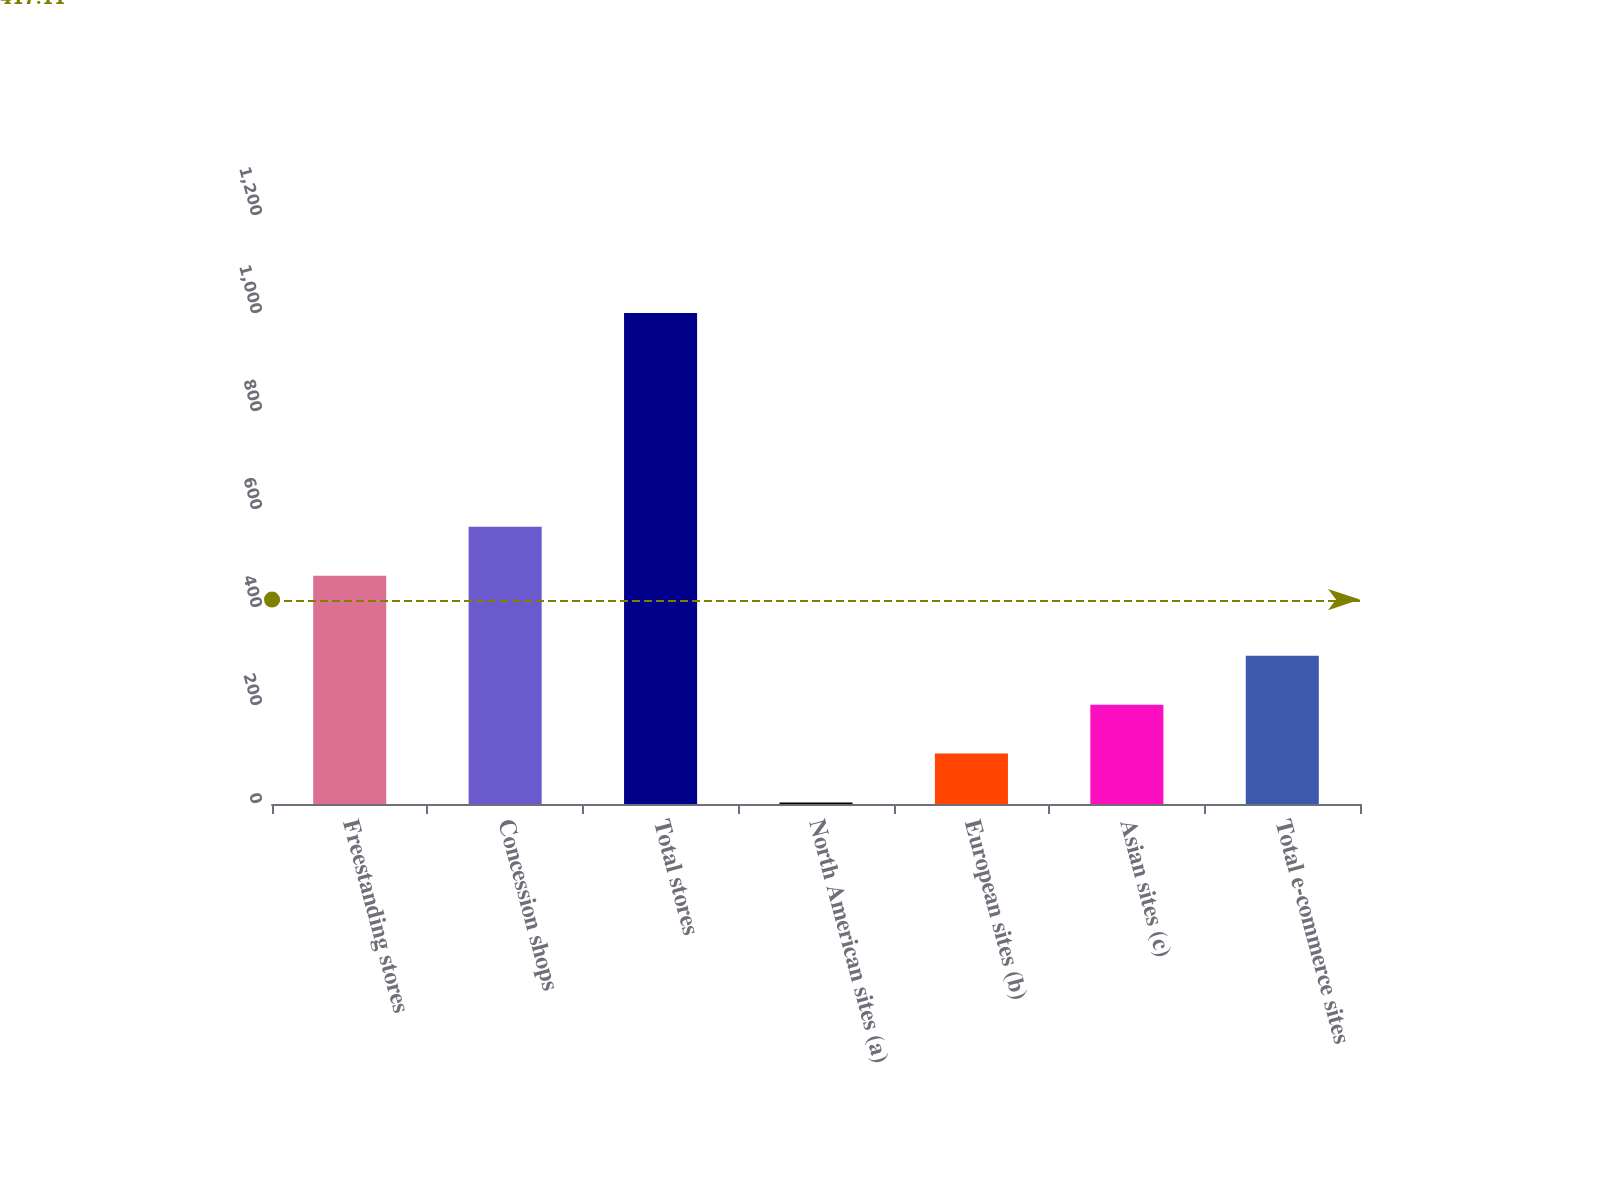Convert chart to OTSL. <chart><loc_0><loc_0><loc_500><loc_500><bar_chart><fcel>Freestanding stores<fcel>Concession shops<fcel>Total stores<fcel>North American sites (a)<fcel>European sites (b)<fcel>Asian sites (c)<fcel>Total e-commerce sites<nl><fcel>466<fcel>565.9<fcel>1002<fcel>3<fcel>102.9<fcel>202.8<fcel>302.7<nl></chart> 